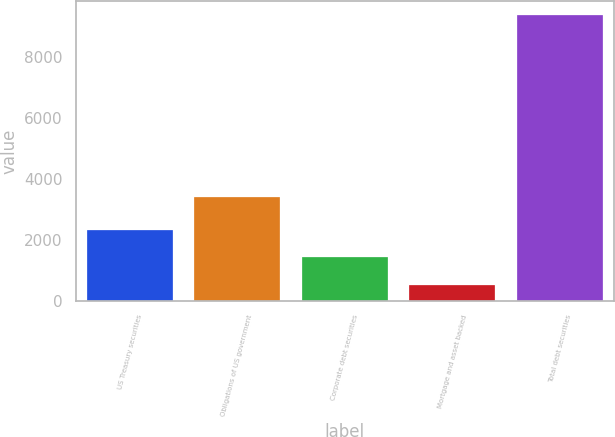Convert chart to OTSL. <chart><loc_0><loc_0><loc_500><loc_500><bar_chart><fcel>US Treasury securities<fcel>Obligations of US government<fcel>Corporate debt securities<fcel>Mortgage and asset backed<fcel>Total debt securities<nl><fcel>2317<fcel>3396<fcel>1432<fcel>508<fcel>9358<nl></chart> 